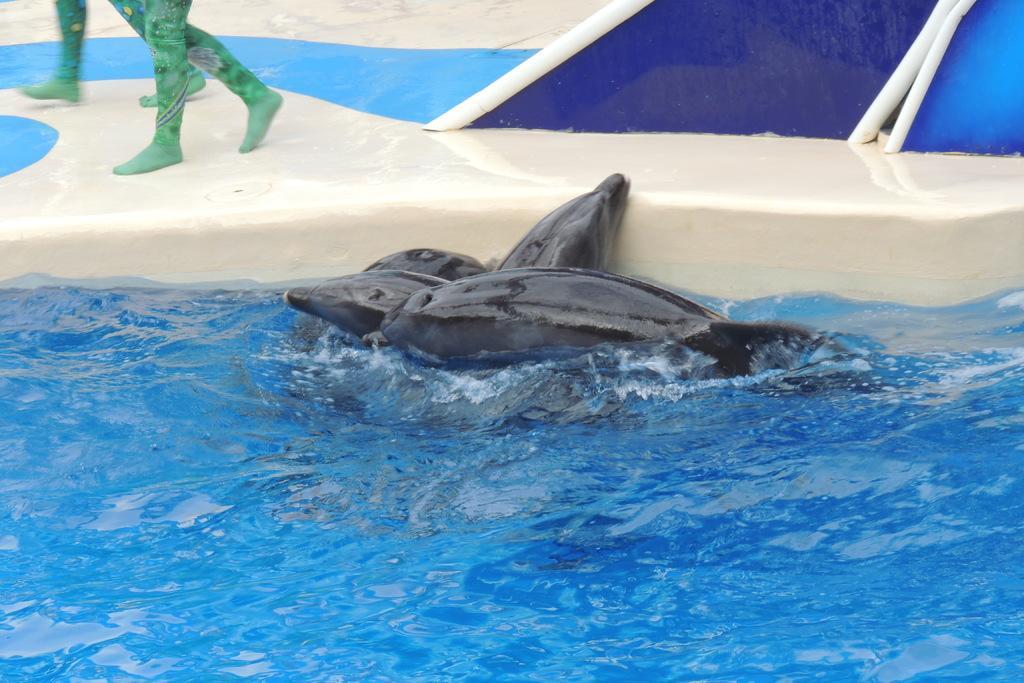Could you give a brief overview of what you see in this image? In this picture we can see dolphins in the water and in the background we can see two people are walking on a platform. 